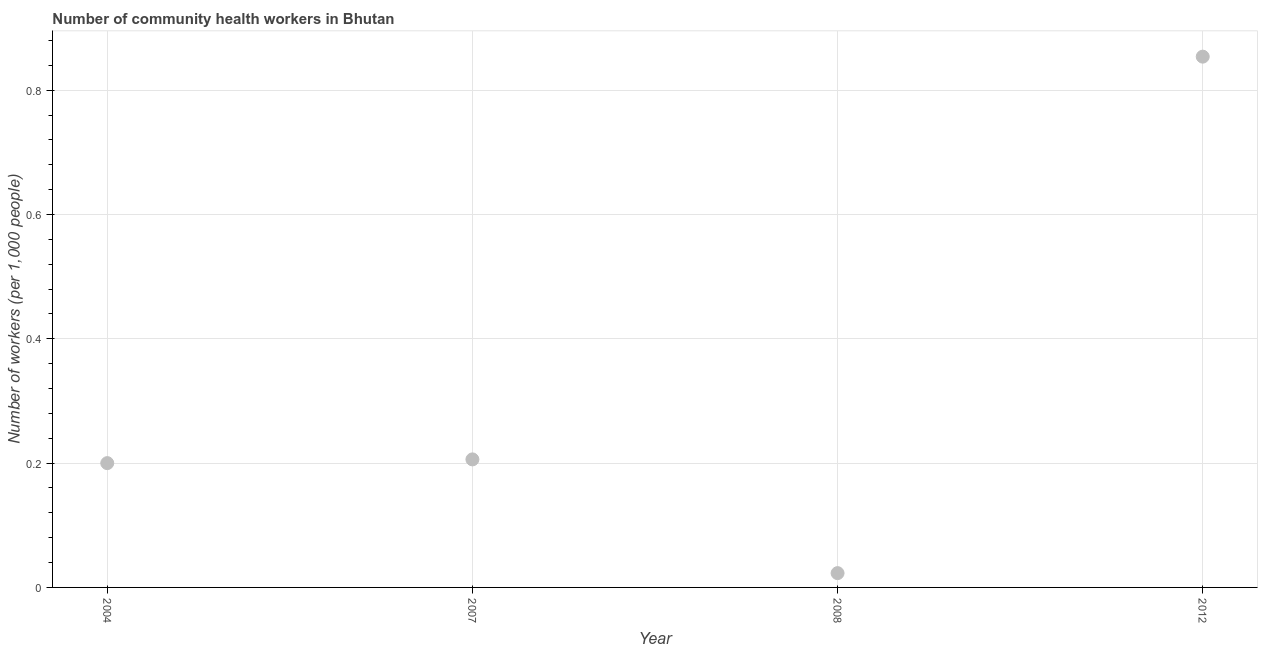What is the number of community health workers in 2012?
Make the answer very short. 0.85. Across all years, what is the maximum number of community health workers?
Offer a terse response. 0.85. Across all years, what is the minimum number of community health workers?
Offer a terse response. 0.02. In which year was the number of community health workers minimum?
Your answer should be very brief. 2008. What is the sum of the number of community health workers?
Keep it short and to the point. 1.28. What is the difference between the number of community health workers in 2004 and 2012?
Make the answer very short. -0.65. What is the average number of community health workers per year?
Your answer should be compact. 0.32. What is the median number of community health workers?
Your answer should be very brief. 0.2. Do a majority of the years between 2012 and 2008 (inclusive) have number of community health workers greater than 0.12 ?
Give a very brief answer. No. What is the ratio of the number of community health workers in 2008 to that in 2012?
Your response must be concise. 0.03. Is the number of community health workers in 2007 less than that in 2008?
Your answer should be very brief. No. Is the difference between the number of community health workers in 2008 and 2012 greater than the difference between any two years?
Offer a terse response. Yes. What is the difference between the highest and the second highest number of community health workers?
Give a very brief answer. 0.65. Is the sum of the number of community health workers in 2008 and 2012 greater than the maximum number of community health workers across all years?
Provide a short and direct response. Yes. What is the difference between the highest and the lowest number of community health workers?
Give a very brief answer. 0.83. In how many years, is the number of community health workers greater than the average number of community health workers taken over all years?
Your response must be concise. 1. Does the number of community health workers monotonically increase over the years?
Provide a succinct answer. No. How many years are there in the graph?
Offer a terse response. 4. Are the values on the major ticks of Y-axis written in scientific E-notation?
Provide a succinct answer. No. Does the graph contain any zero values?
Ensure brevity in your answer.  No. What is the title of the graph?
Offer a terse response. Number of community health workers in Bhutan. What is the label or title of the X-axis?
Provide a succinct answer. Year. What is the label or title of the Y-axis?
Offer a terse response. Number of workers (per 1,0 people). What is the Number of workers (per 1,000 people) in 2007?
Offer a very short reply. 0.21. What is the Number of workers (per 1,000 people) in 2008?
Keep it short and to the point. 0.02. What is the Number of workers (per 1,000 people) in 2012?
Keep it short and to the point. 0.85. What is the difference between the Number of workers (per 1,000 people) in 2004 and 2007?
Ensure brevity in your answer.  -0.01. What is the difference between the Number of workers (per 1,000 people) in 2004 and 2008?
Offer a very short reply. 0.18. What is the difference between the Number of workers (per 1,000 people) in 2004 and 2012?
Give a very brief answer. -0.65. What is the difference between the Number of workers (per 1,000 people) in 2007 and 2008?
Give a very brief answer. 0.18. What is the difference between the Number of workers (per 1,000 people) in 2007 and 2012?
Provide a short and direct response. -0.65. What is the difference between the Number of workers (per 1,000 people) in 2008 and 2012?
Give a very brief answer. -0.83. What is the ratio of the Number of workers (per 1,000 people) in 2004 to that in 2008?
Offer a very short reply. 8.7. What is the ratio of the Number of workers (per 1,000 people) in 2004 to that in 2012?
Your answer should be compact. 0.23. What is the ratio of the Number of workers (per 1,000 people) in 2007 to that in 2008?
Ensure brevity in your answer.  8.96. What is the ratio of the Number of workers (per 1,000 people) in 2007 to that in 2012?
Your answer should be compact. 0.24. What is the ratio of the Number of workers (per 1,000 people) in 2008 to that in 2012?
Ensure brevity in your answer.  0.03. 